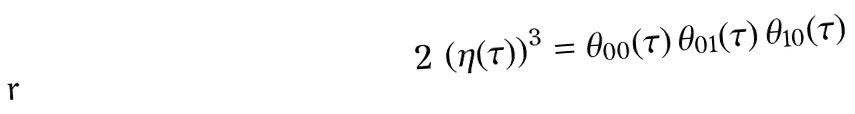Convert formula to latex. <formula><loc_0><loc_0><loc_500><loc_500>2 \, \left ( \eta ( \tau ) \right ) ^ { 3 } = \theta _ { 0 0 } ( \tau ) \, \theta _ { 0 1 } ( \tau ) \, \theta _ { 1 0 } ( \tau )</formula> 